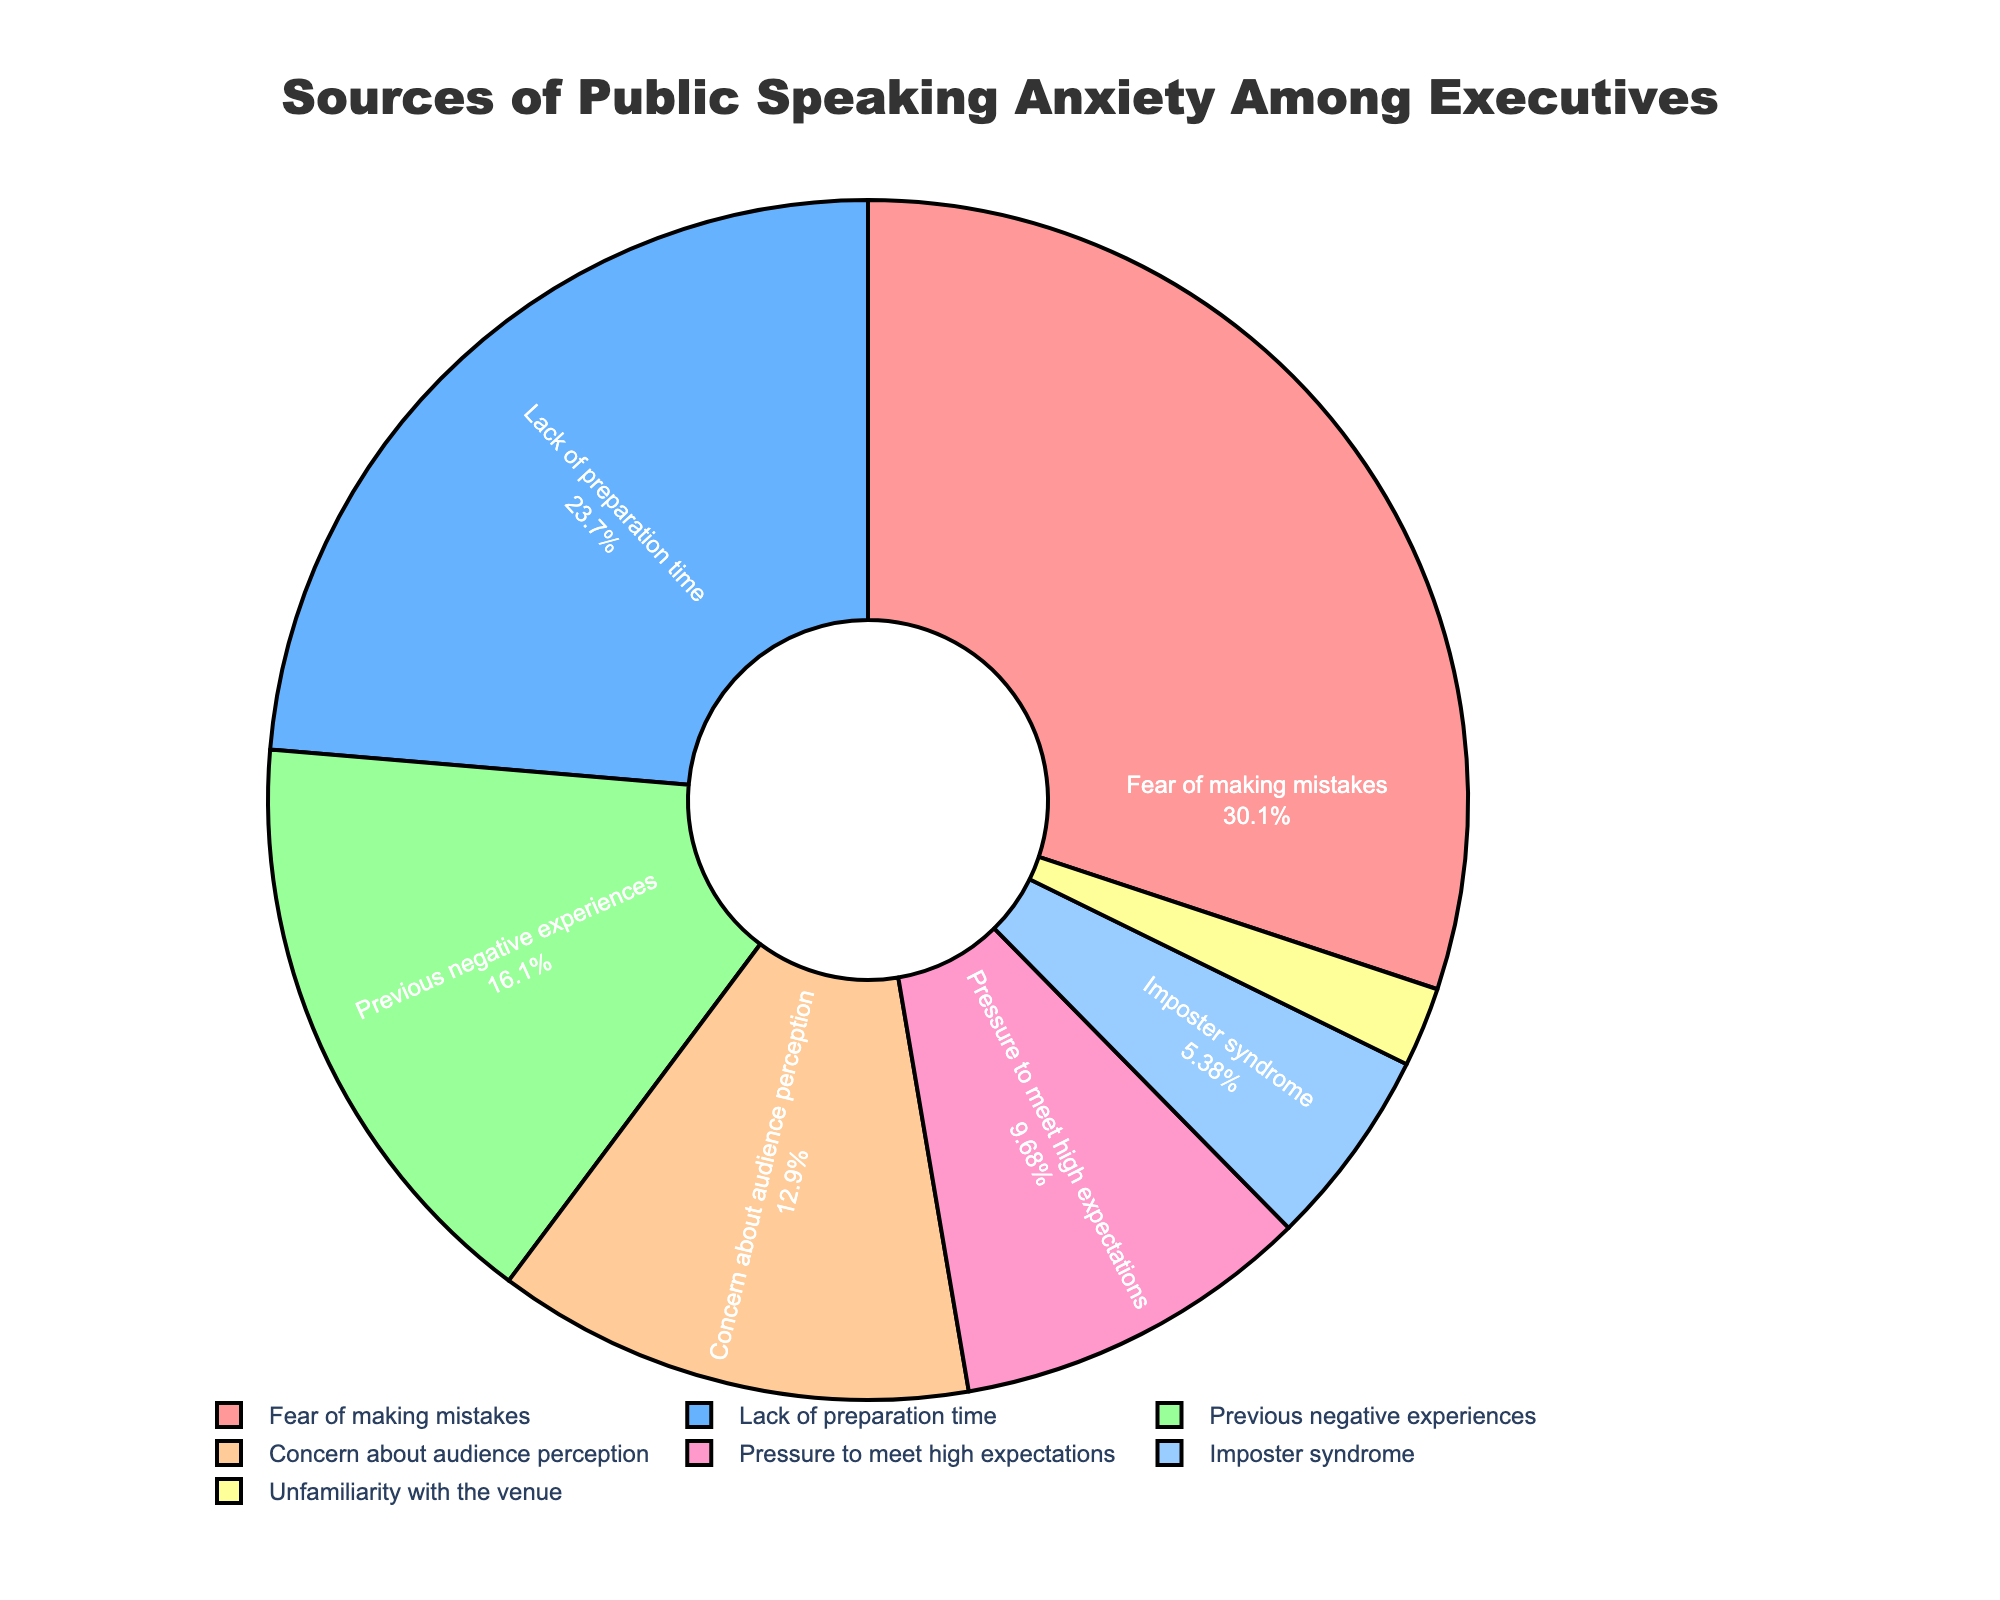Which source of public speaking anxiety is the most significant among executives? The slice labelled "Fear of making mistakes" occupies the largest portion of the pie chart, indicating it is the most significant source with 28%.
Answer: Fear of making mistakes What is the combined percentage of anxiety sources related to internal feelings (like imposter syndrome and concern about audience perception)? The percentage for "Imposter syndrome" is 5% and for "Concern about audience perception" is 12%. Adding these together gives 5% + 12% = 17%.
Answer: 17% How does the percentage of "Lack of preparation time" compare to "Fear of making mistakes"? The "Lack of preparation time" slice shows 22%, while "Fear of making mistakes" shows 28%. 22% is less than 28%.
Answer: Less What is the difference in percentage between "Pressure to meet high expectations" and "Previous negative experiences"? "Previous negative experiences" have 15% and "Pressure to meet high expectations" has 9%. The difference is 15% - 9% = 6%.
Answer: 6% What portions of the pie chart are depicted in shades of green? The color legend shows the "Unfamiliarity with the venue" and “Previous negative experiences” slices are depicted with shades that look greenish, specifically “Previous negative experiences" is 15% and “Unfamiliarity with the venue” is 2%.
Answer: Previous negative experiences and Unfamiliarity with the venue Which source of public speaking anxiety is the least significant? The smallest slice of the pie chart, representing "Unfamiliarity with the venue", corresponds to 2%.
Answer: Unfamiliarity with the venue By how many percentage points does the "Fear of making mistakes" exceed "Concern about audience perception"? The percentage of "Fear of making mistakes" is 28% while "Concern about audience perception" is 12%. 28% - 12% = 16%.
Answer: 16% If you combine the percentage values for "Previous negative experiences" and "Lack of preparation time," how does it compare to "Fear of making mistakes"? "Previous negative experiences" is 15% and "Lack of preparation time" is 22%. Adding these together gives 15% + 22% = 37%, which is greater than "Fear of making mistakes" at 28%.
Answer: Greater What percentage of public speaking anxiety sources is not related to internal feelings (those other than imposter syndrome and concern about audience perception)? To find the answer, subtract the combined percentage of "Imposter syndrome" and "Concern about audience perception" from 100%. The combined percentage is 17%. So, 100% - 17% = 83%.
Answer: 83% How much more significant is "Lack of preparation time" compared to "Pressure to meet high expectations"? "Lack of preparation time" is at 22%, while "Pressure to meet high expectations" is at 9%. The difference is 22% - 9% = 13%.
Answer: 13% 